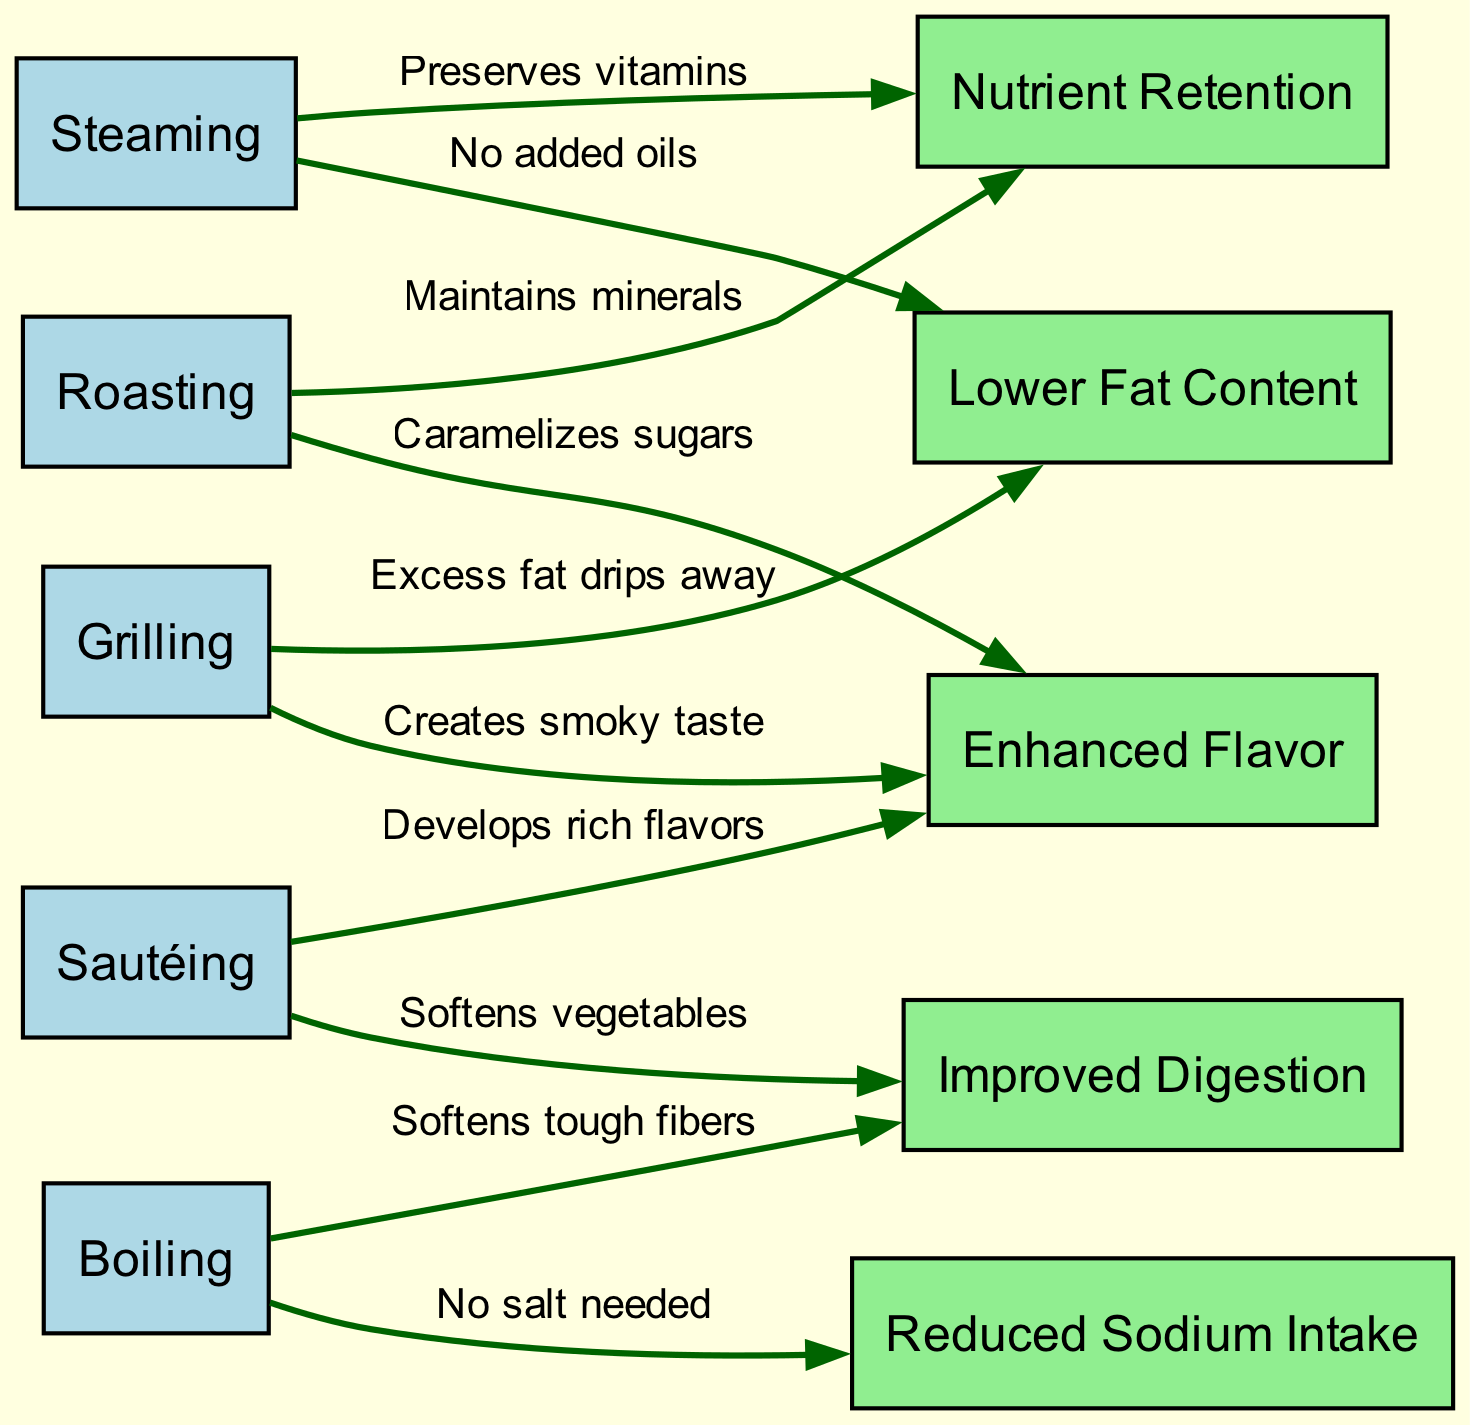What cooking technique is associated with nutrient retention? The diagram shows that "Steaming" has a directed edge to "Nutrient Retention," indicating a direct relationship. Therefore, the answer is "Steaming."
Answer: Steaming What is the health benefit associated with grilling? The diagram connects "Grilling" with two health benefits: "Lower Fat Content" and "Enhanced Flavor." Therefore, either of these is a correct response, based on the specific focus.
Answer: Lower Fat Content How many techniques are represented in the diagram? Counting the nodes categorized as cooking techniques, we find five: "Steaming," "Grilling," "Sautéing," "Roasting," and "Boiling." Therefore, the total number is five.
Answer: 5 Which method leads to improved digestion? There are two methods that lead to "Improved Digestion": "Sautéing" and "Boiling." Each technique is linked to improved digestion according to the diagram.
Answer: Sautéing What health benefit is connected to boiling? According to the directed edges related to "Boiling," it connects primarily to "Reduced Sodium Intake" and "Improved Digestion." Hence, both are valid answers, depending on interpretation.
Answer: Reduced Sodium Intake What is the common health benefit shared by roasting and steaming? The diagram indicates that both "Roasting" and "Steaming" have directed edges to "Nutrient Retention," signifying they share this health benefit.
Answer: Nutrient Retention Which cooking technique enhances flavor through caramelization? Referring to the diagram, "Roasting" is shown to directly lead to "Enhanced Flavor" via caramelization of sugars, signifying the relationship.
Answer: Roasting How does sautéing contribute to health? "Sautéing" correlates with two health benefits: "Enhanced Flavor" and "Improved Digestion." This shows its contribution to health through both flavor and digestibility.
Answer: Improved Digestion What type of edge connects cooking techniques to health benefits? The edges in the directed graph indicate the relationships specifically by showing how techniques relate to their health benefits, which are directed from techniques to benefits.
Answer: Directed edges 